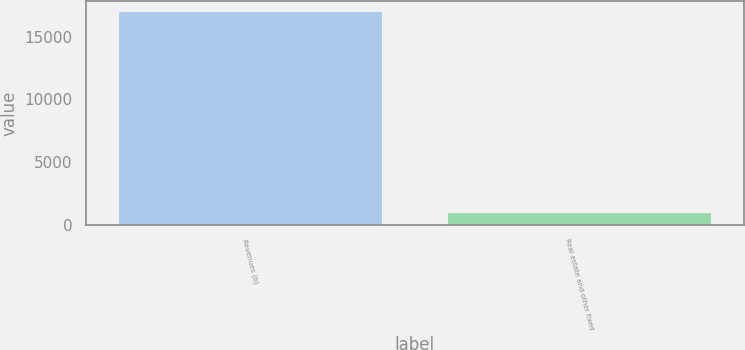Convert chart. <chart><loc_0><loc_0><loc_500><loc_500><bar_chart><fcel>Revenues (b)<fcel>Real estate and other fixed<nl><fcel>17011<fcel>937<nl></chart> 